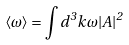Convert formula to latex. <formula><loc_0><loc_0><loc_500><loc_500>\langle \omega \rangle = \int d ^ { 3 } k \, \omega | A | ^ { 2 }</formula> 